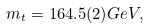<formula> <loc_0><loc_0><loc_500><loc_500>m _ { t } = 1 6 4 . 5 ( 2 ) G e V ,</formula> 